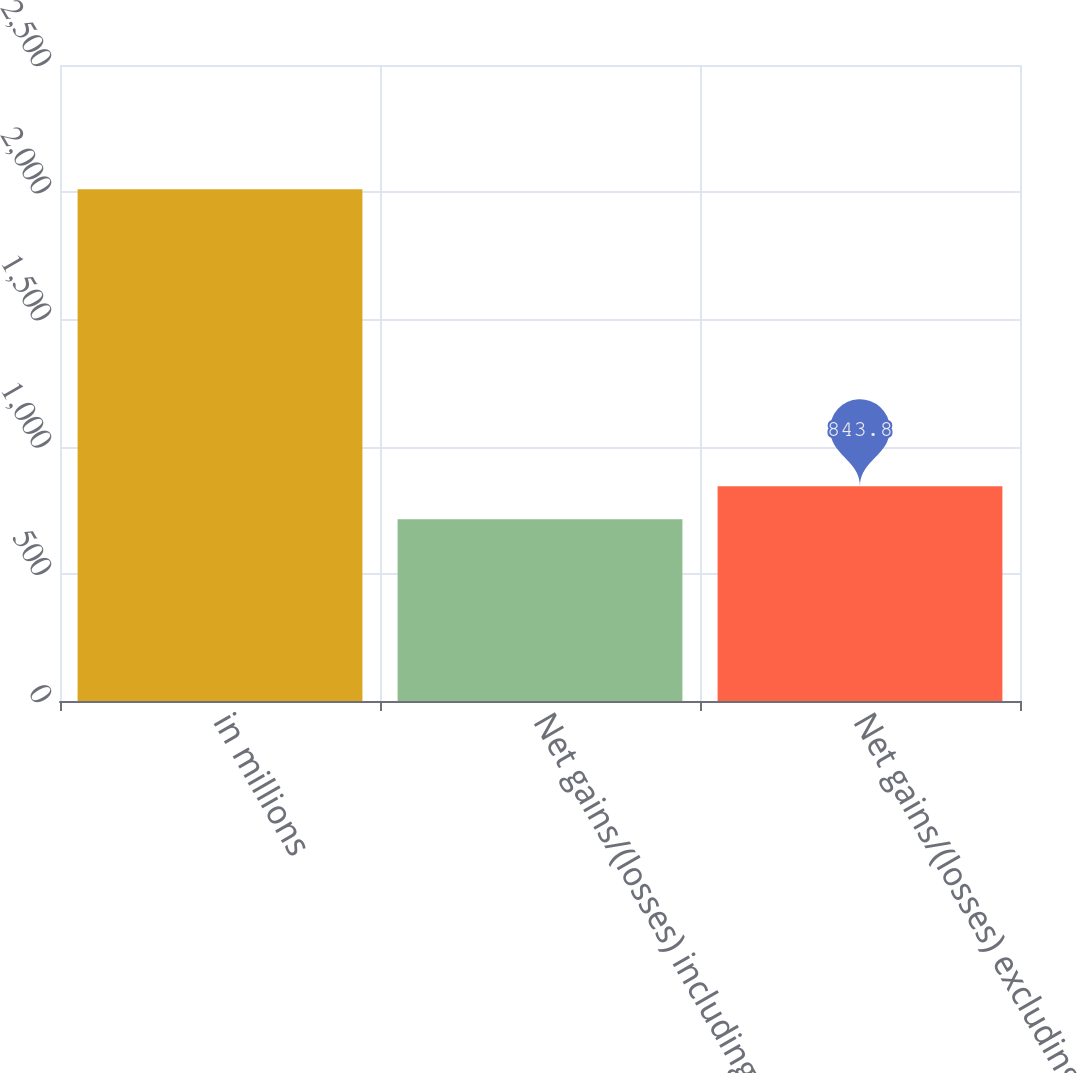<chart> <loc_0><loc_0><loc_500><loc_500><bar_chart><fcel>in millions<fcel>Net gains/(losses) including<fcel>Net gains/(losses) excluding<nl><fcel>2012<fcel>714<fcel>843.8<nl></chart> 